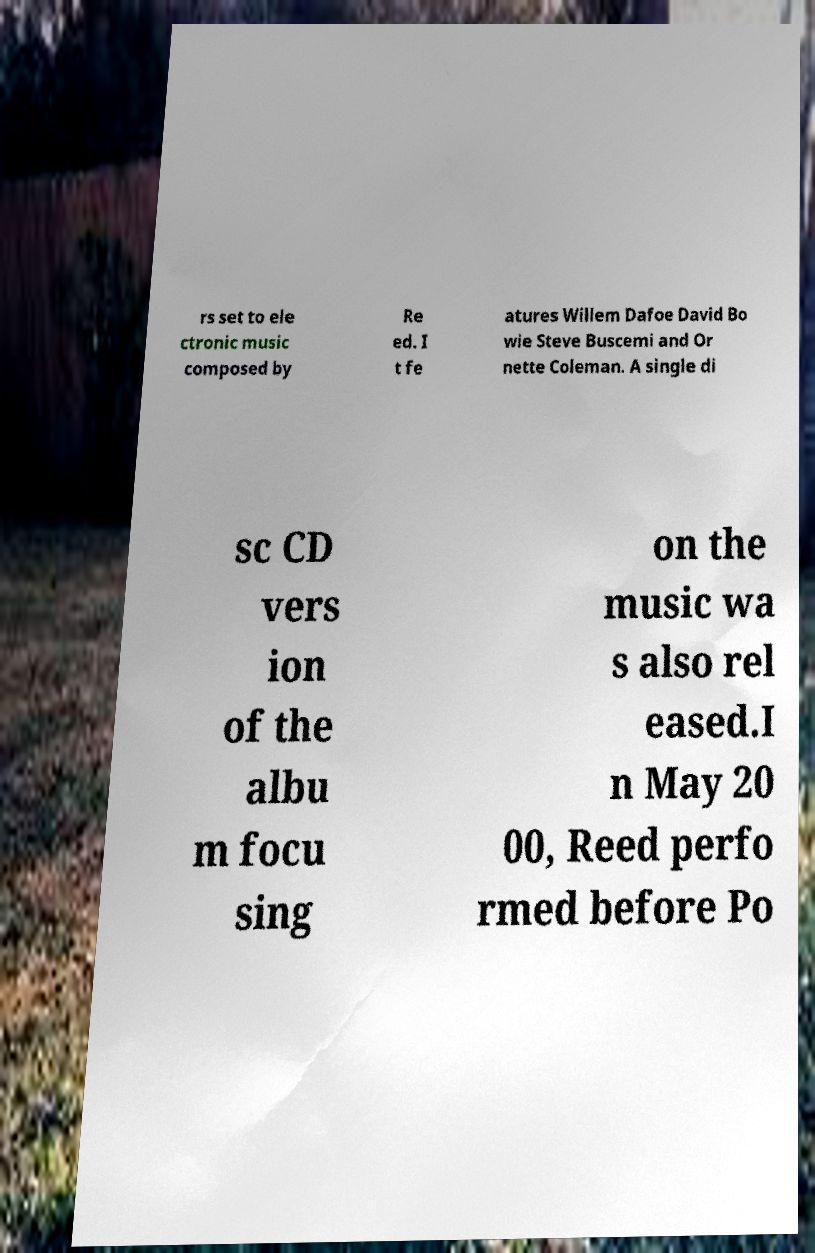There's text embedded in this image that I need extracted. Can you transcribe it verbatim? rs set to ele ctronic music composed by Re ed. I t fe atures Willem Dafoe David Bo wie Steve Buscemi and Or nette Coleman. A single di sc CD vers ion of the albu m focu sing on the music wa s also rel eased.I n May 20 00, Reed perfo rmed before Po 